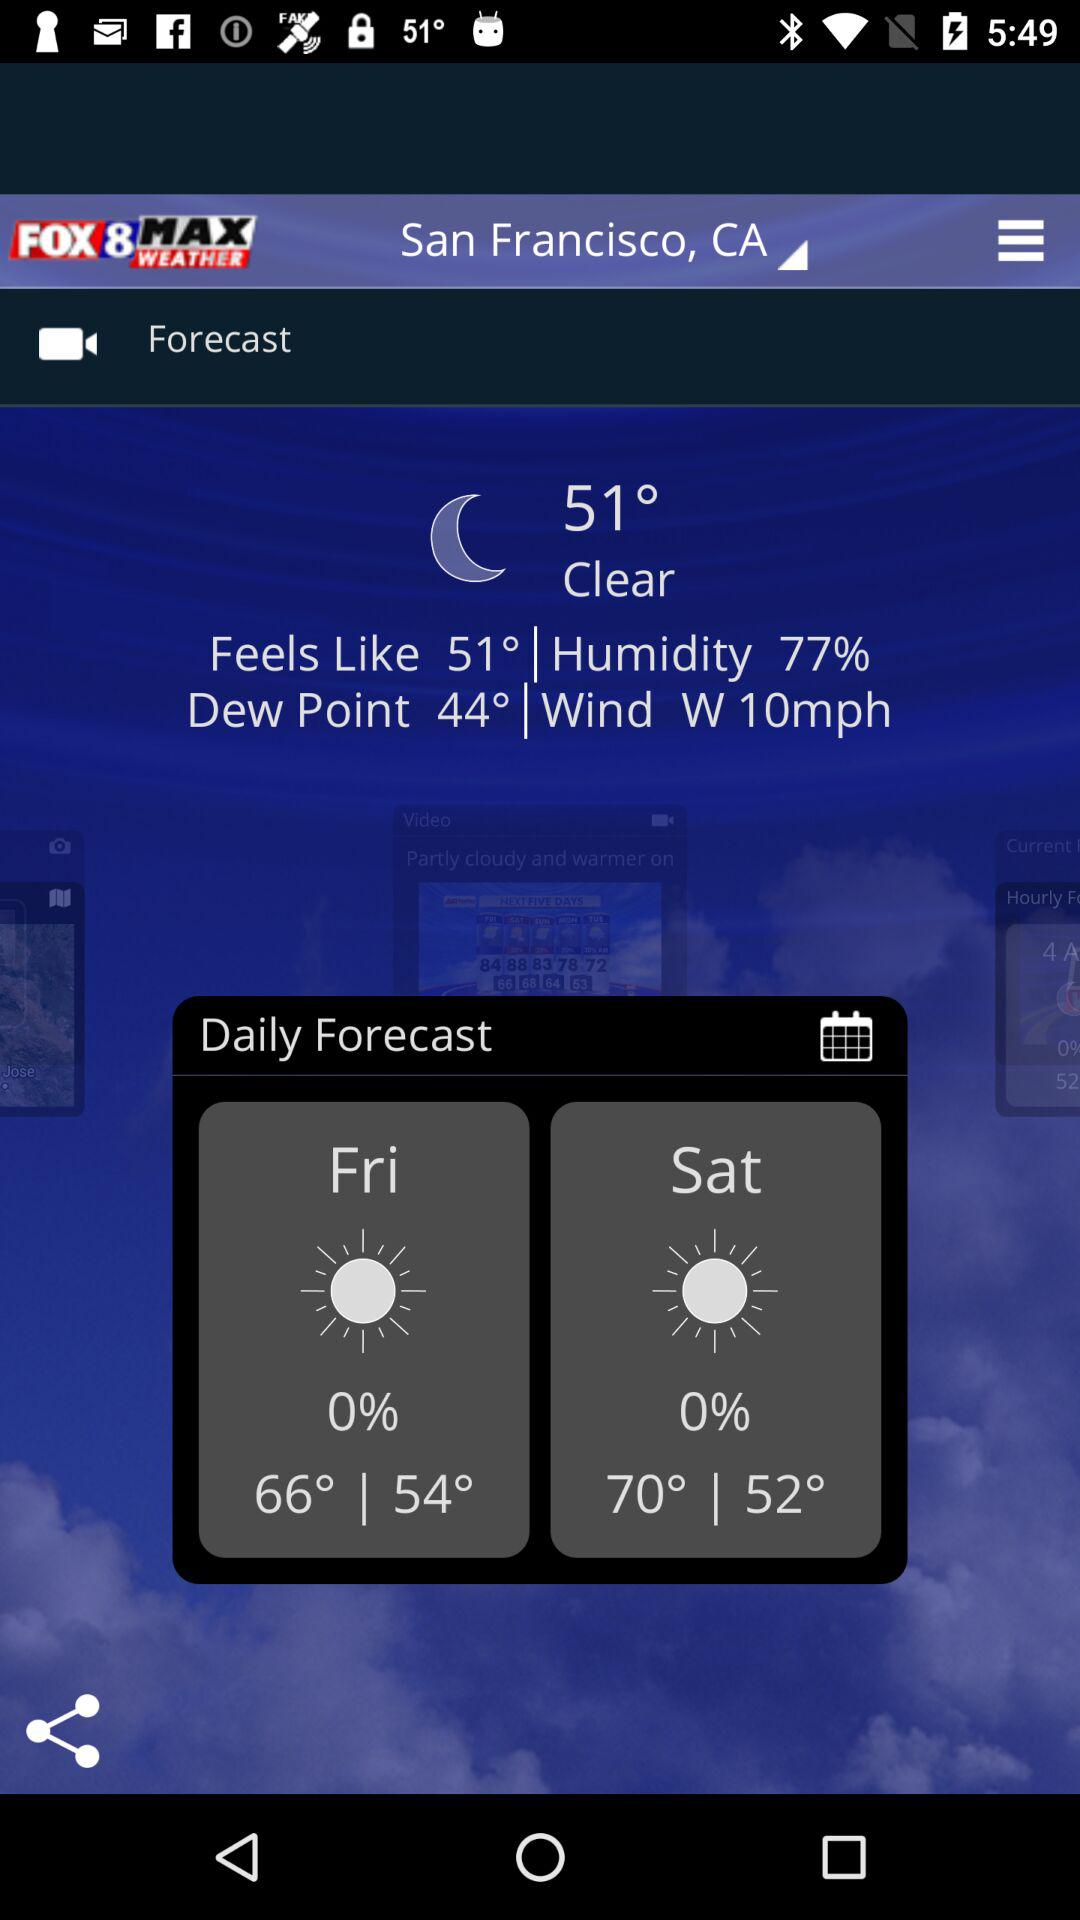How is the mentioned weather? The mentioned weather is clear. 